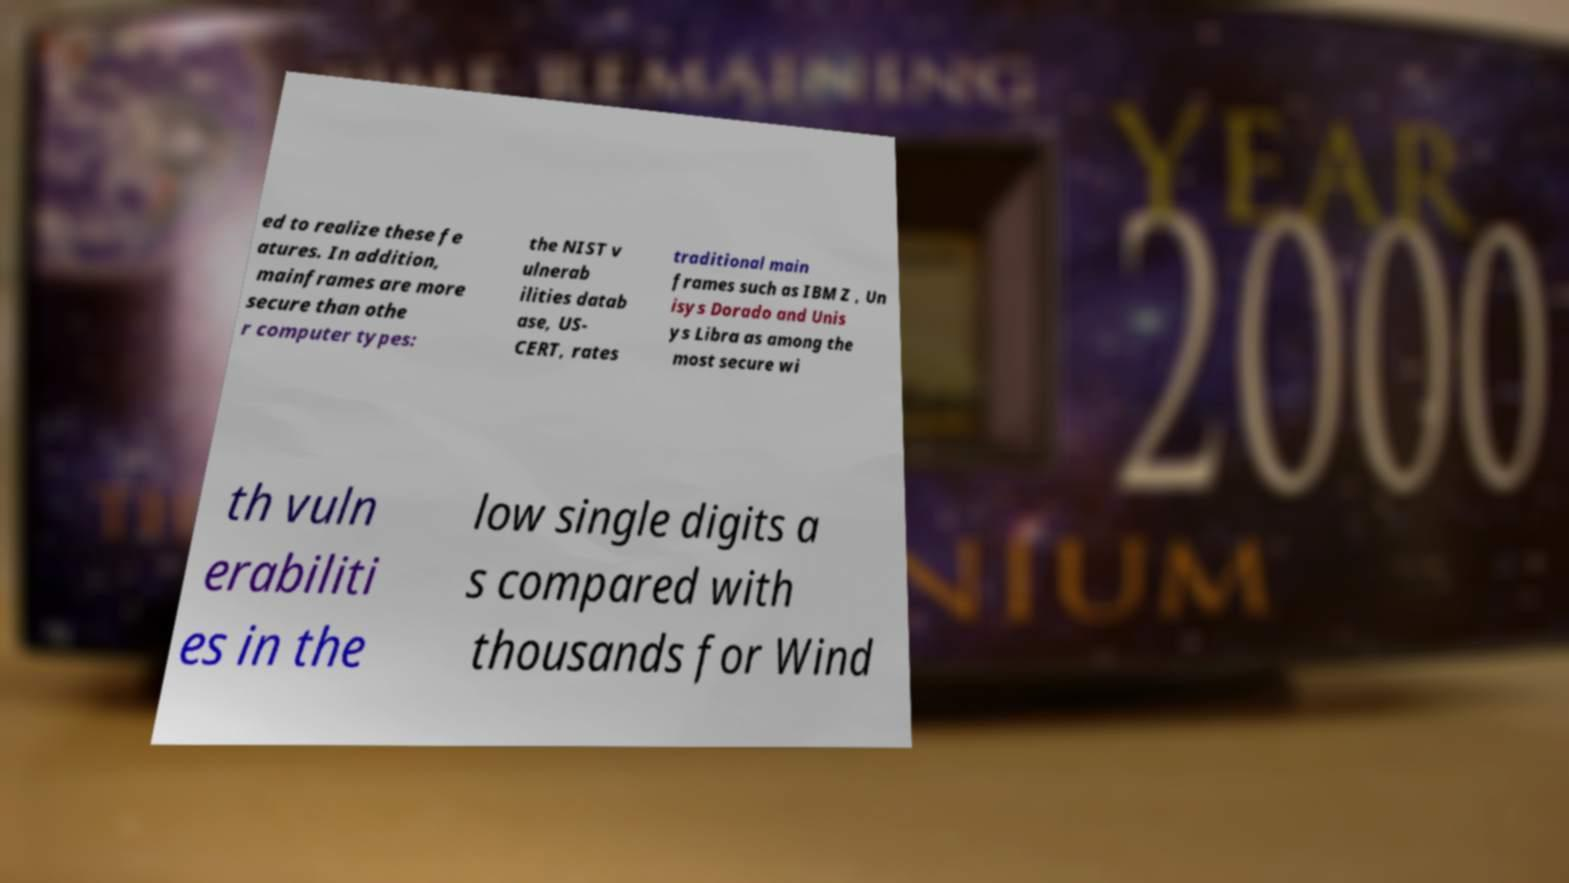Can you accurately transcribe the text from the provided image for me? ed to realize these fe atures. In addition, mainframes are more secure than othe r computer types: the NIST v ulnerab ilities datab ase, US- CERT, rates traditional main frames such as IBM Z , Un isys Dorado and Unis ys Libra as among the most secure wi th vuln erabiliti es in the low single digits a s compared with thousands for Wind 